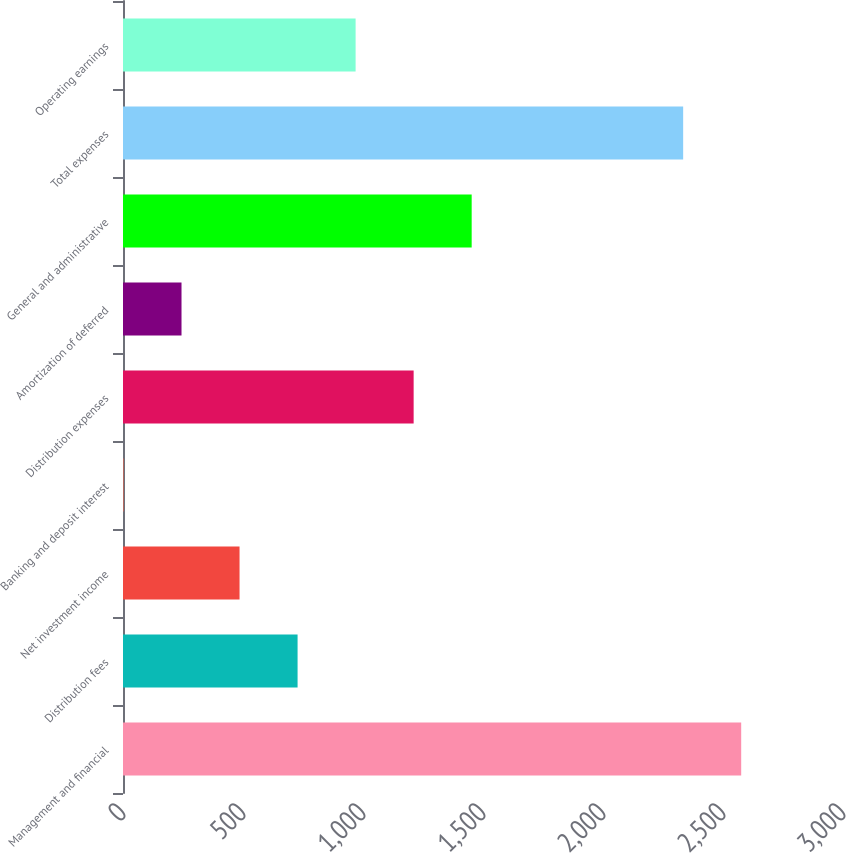Convert chart. <chart><loc_0><loc_0><loc_500><loc_500><bar_chart><fcel>Management and financial<fcel>Distribution fees<fcel>Net investment income<fcel>Banking and deposit interest<fcel>Distribution expenses<fcel>Amortization of deferred<fcel>General and administrative<fcel>Total expenses<fcel>Operating earnings<nl><fcel>2575.8<fcel>727.4<fcel>485.6<fcel>2<fcel>1211<fcel>243.8<fcel>1452.8<fcel>2334<fcel>969.2<nl></chart> 